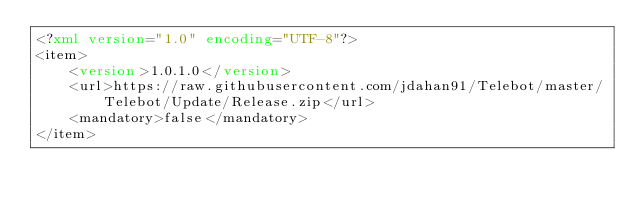Convert code to text. <code><loc_0><loc_0><loc_500><loc_500><_XML_><?xml version="1.0" encoding="UTF-8"?>
<item>
    <version>1.0.1.0</version>
    <url>https://raw.githubusercontent.com/jdahan91/Telebot/master/Telebot/Update/Release.zip</url>
    <mandatory>false</mandatory>
</item></code> 